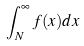<formula> <loc_0><loc_0><loc_500><loc_500>\int _ { N } ^ { \infty } f ( x ) d x</formula> 